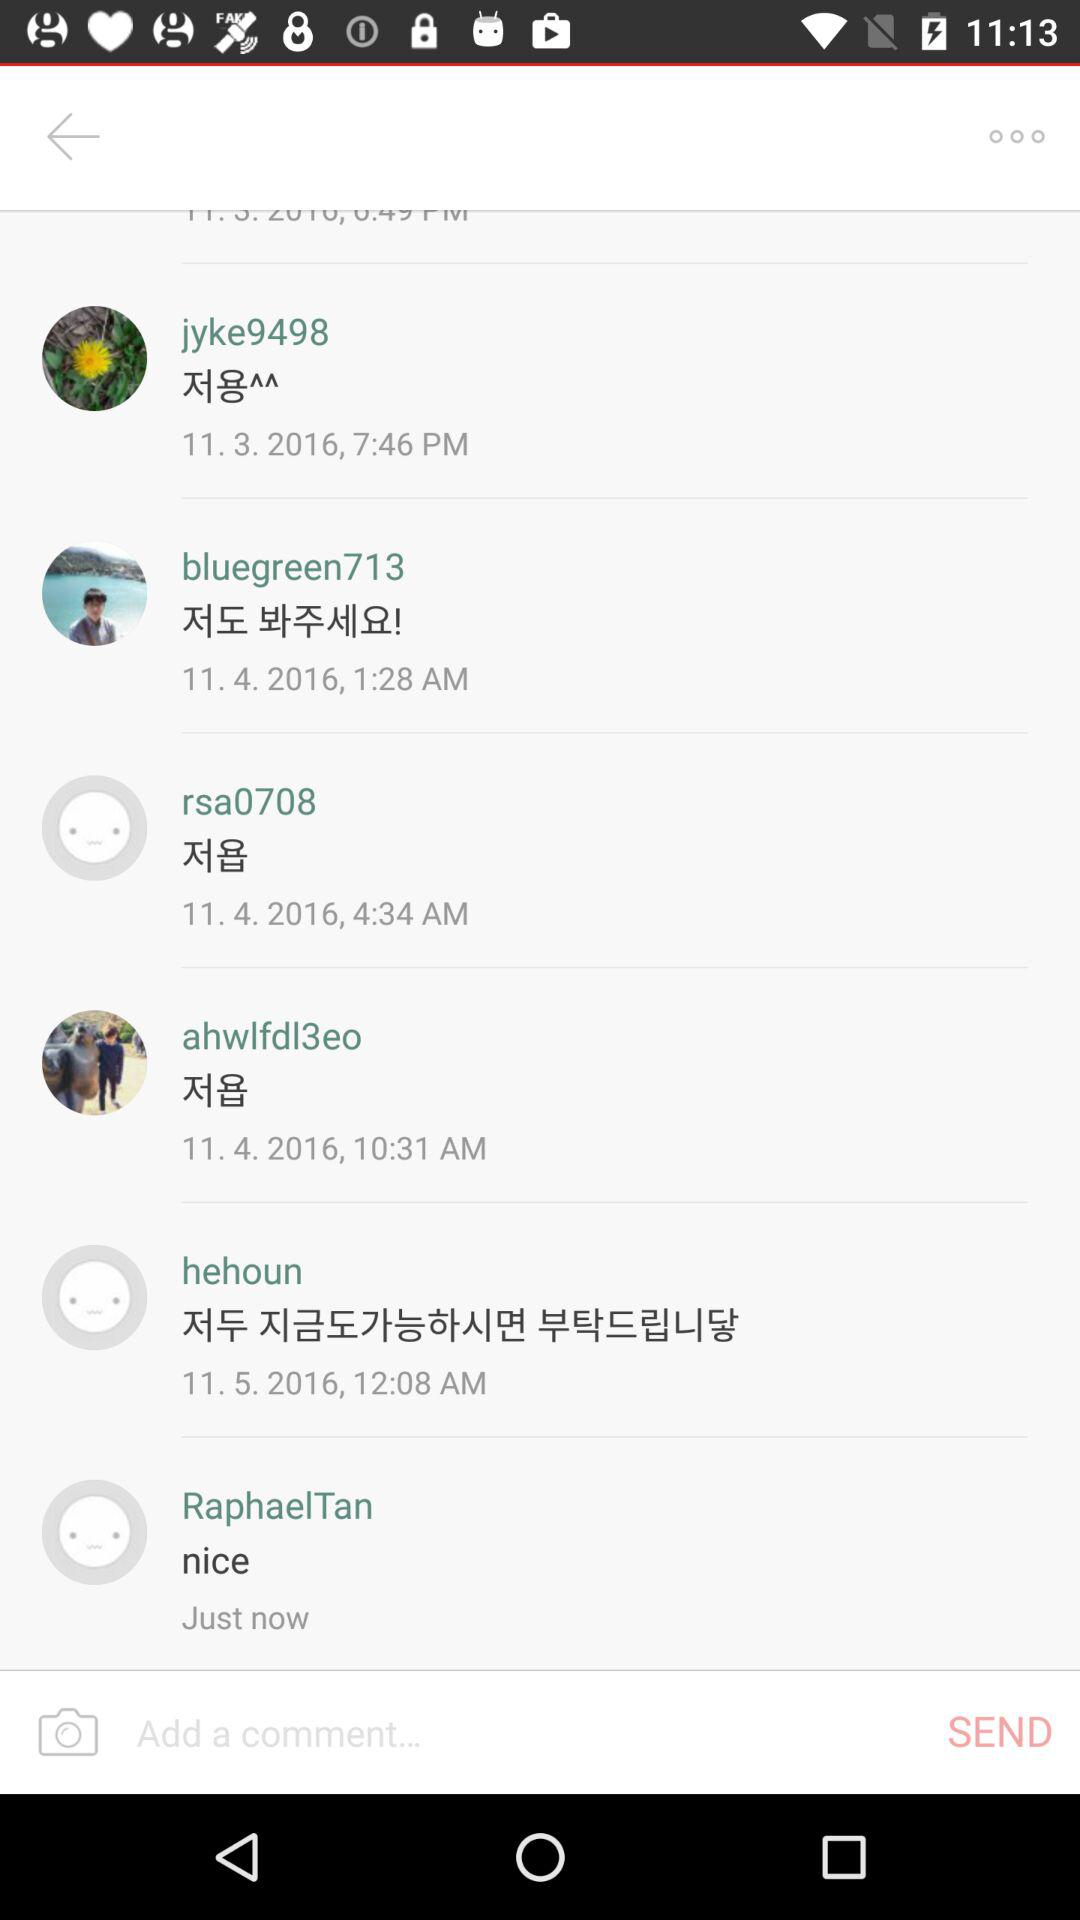Who posted the most recent comment?
Answer the question using a single word or phrase. Raphael Tan 